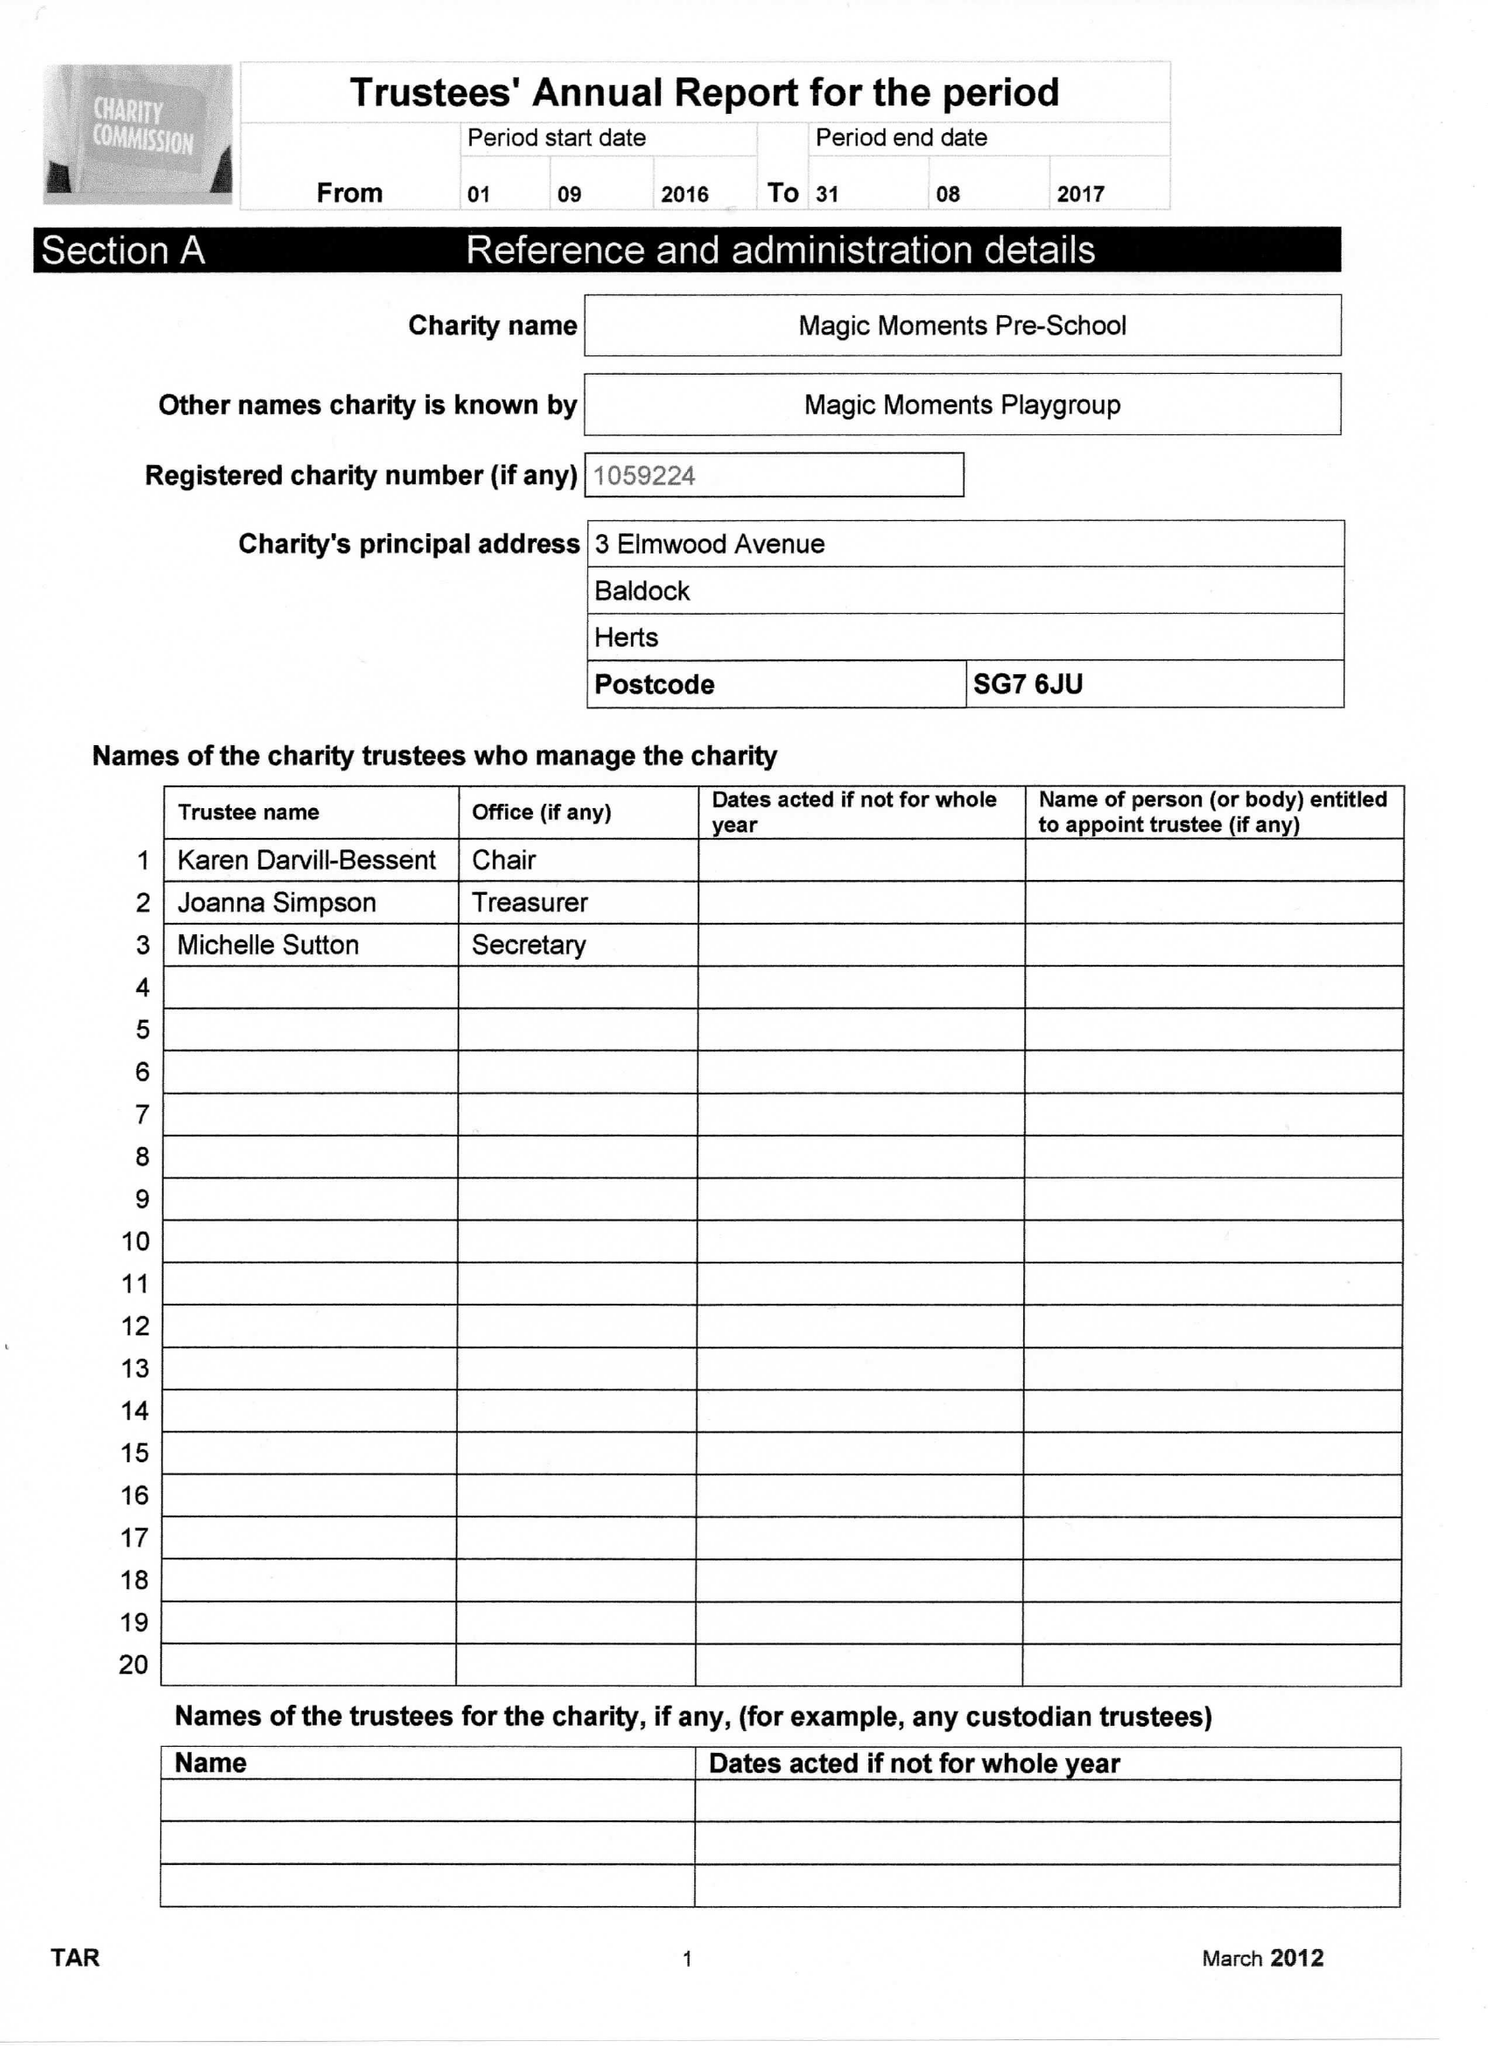What is the value for the address__post_town?
Answer the question using a single word or phrase. BALDOCK 